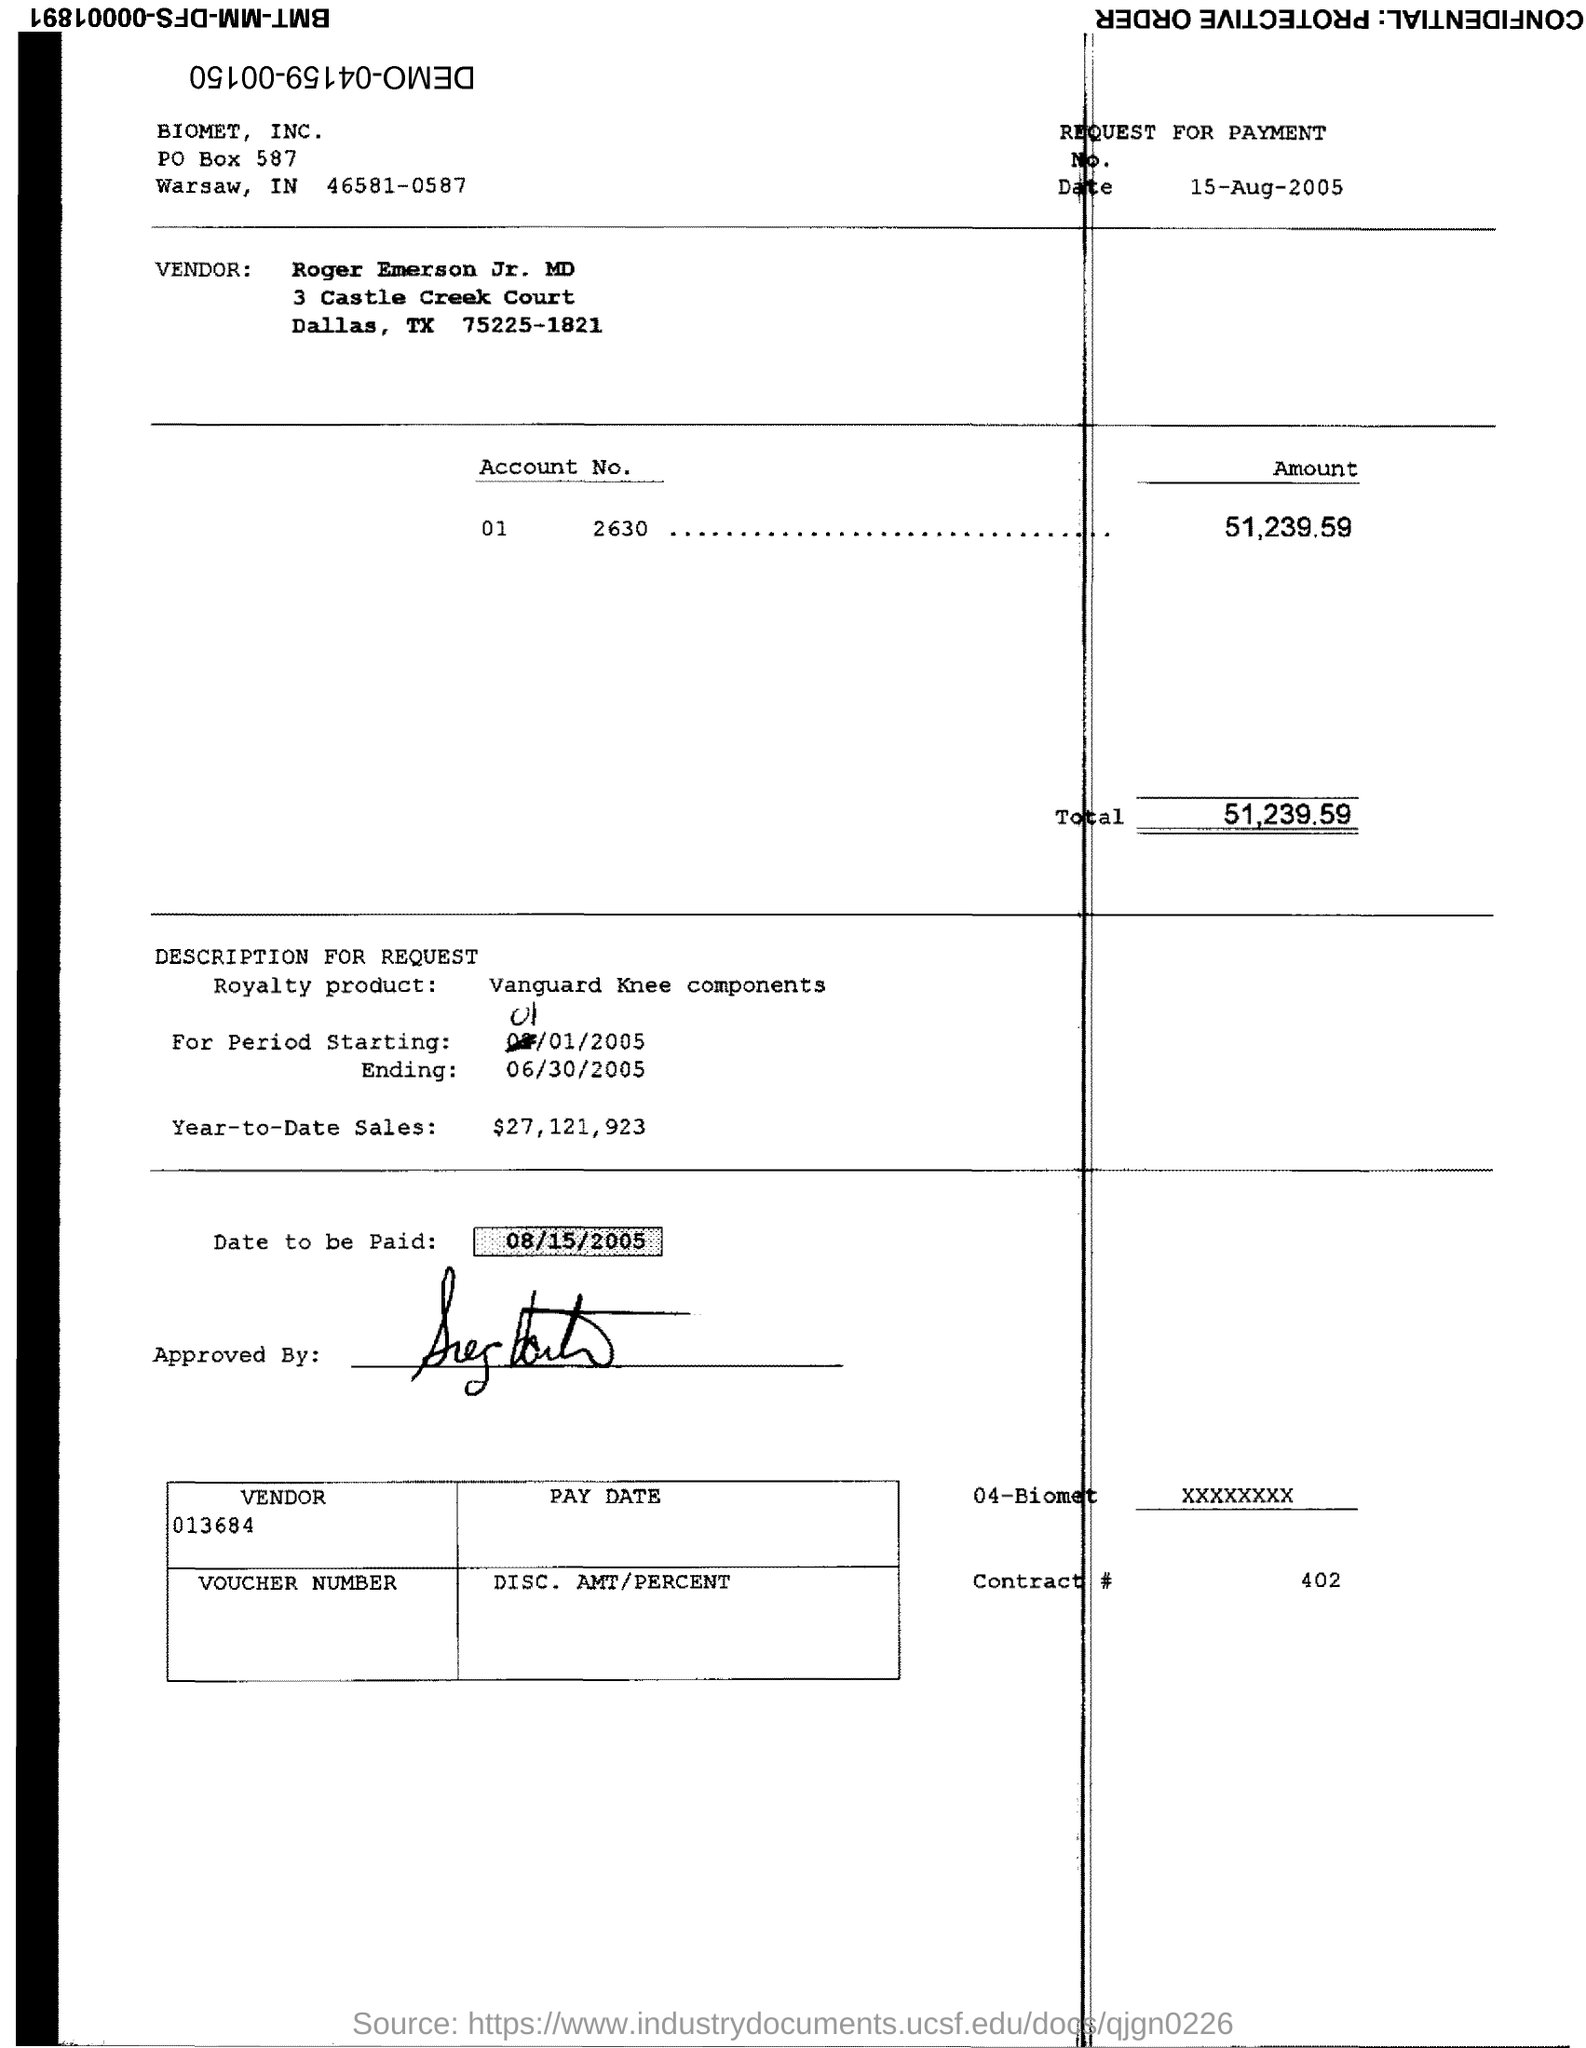Mention a couple of crucial points in this snapshot. The date to be paid is August 15, 2005. The total is 51,239, with an additional amount that has not been specified. 